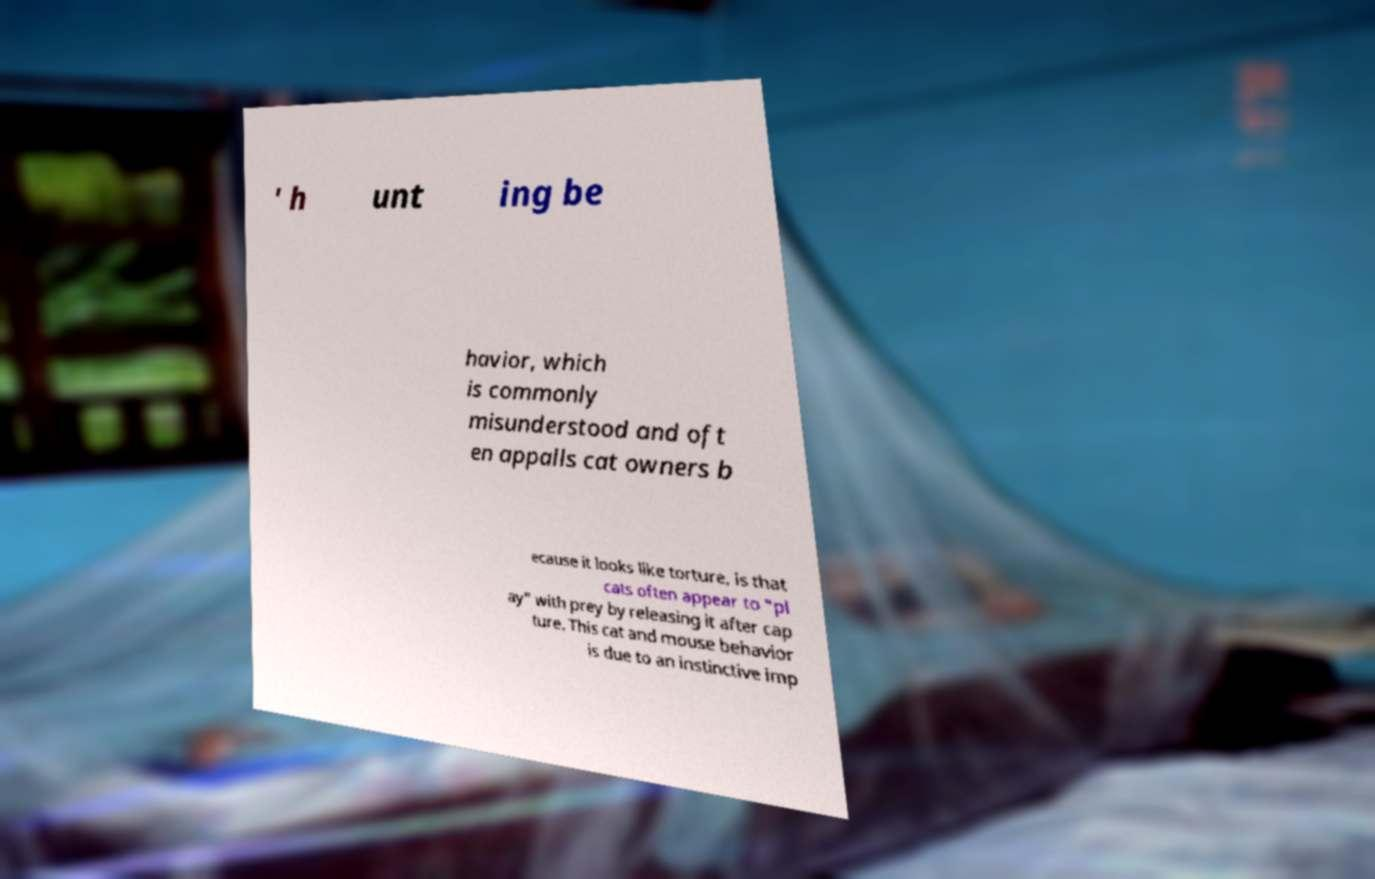What messages or text are displayed in this image? I need them in a readable, typed format. ' h unt ing be havior, which is commonly misunderstood and oft en appalls cat owners b ecause it looks like torture, is that cats often appear to "pl ay" with prey by releasing it after cap ture. This cat and mouse behavior is due to an instinctive imp 